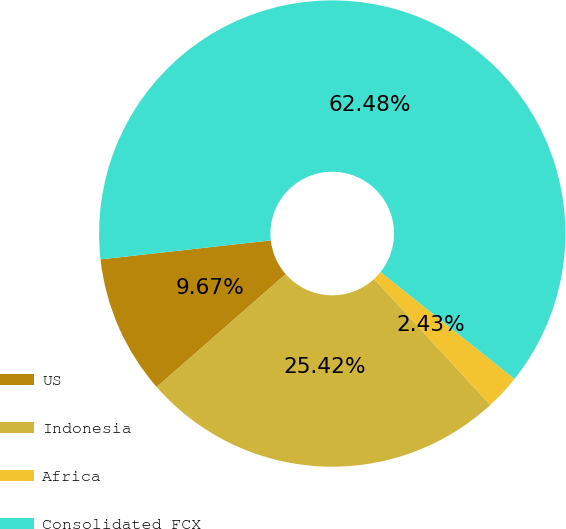Convert chart. <chart><loc_0><loc_0><loc_500><loc_500><pie_chart><fcel>US<fcel>Indonesia<fcel>Africa<fcel>Consolidated FCX<nl><fcel>9.67%<fcel>25.42%<fcel>2.43%<fcel>62.48%<nl></chart> 